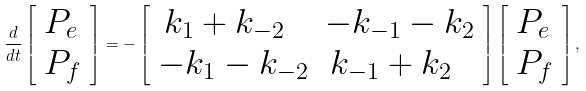<formula> <loc_0><loc_0><loc_500><loc_500>\frac { d } { d t } \left [ \begin{array} { l } P _ { e } \\ P _ { f } \end{array} \right ] = - \left [ \begin{array} { l l } \, k _ { 1 } + k _ { - 2 } & - k _ { - 1 } - k _ { 2 } \\ - k _ { 1 } - k _ { - 2 } & \, k _ { - 1 } + k _ { 2 } \end{array} \right ] \left [ \begin{array} { l } P _ { e } \\ P _ { f } \end{array} \right ] ,</formula> 